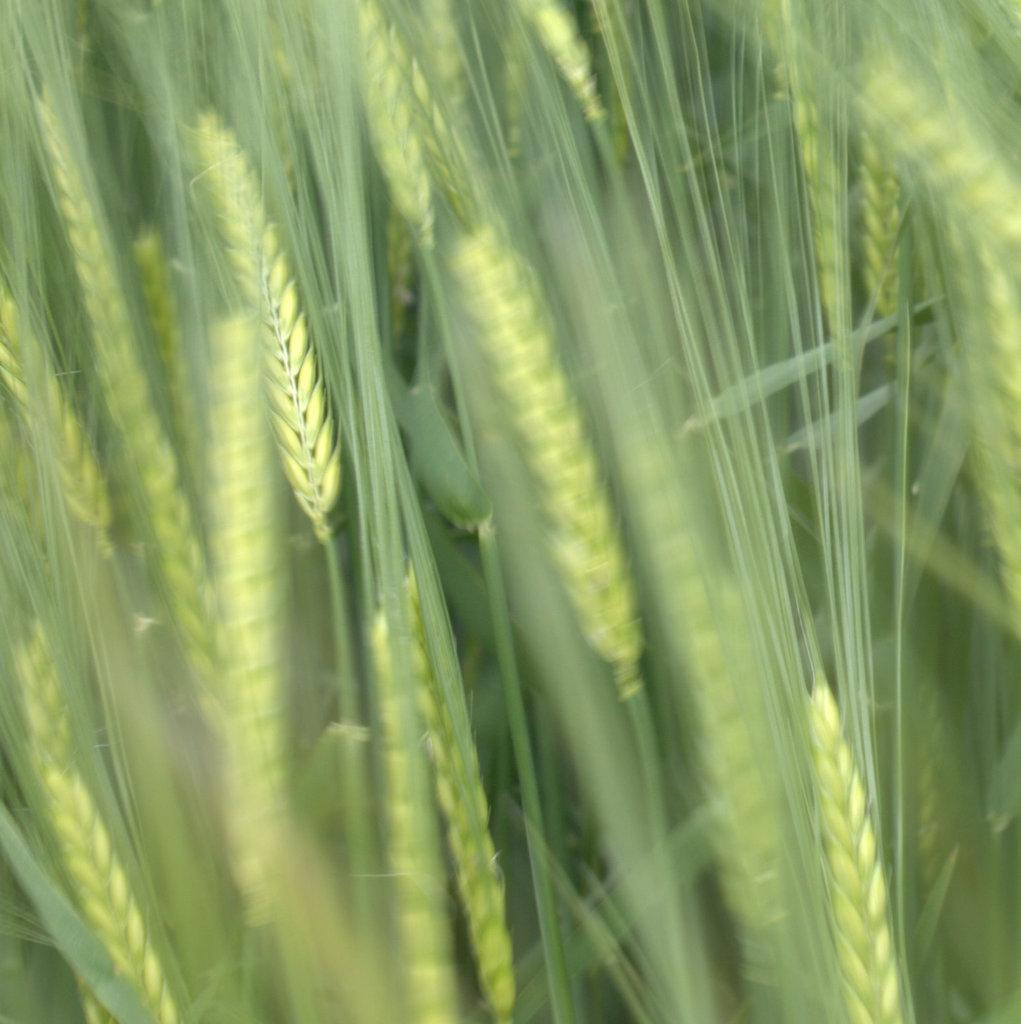What type of plants are visible in the image? There are green plants in the image. Can you tell me how many berries are on the man's cup in the image? There is no man or cup present in the image, and therefore no berries can be observed. 